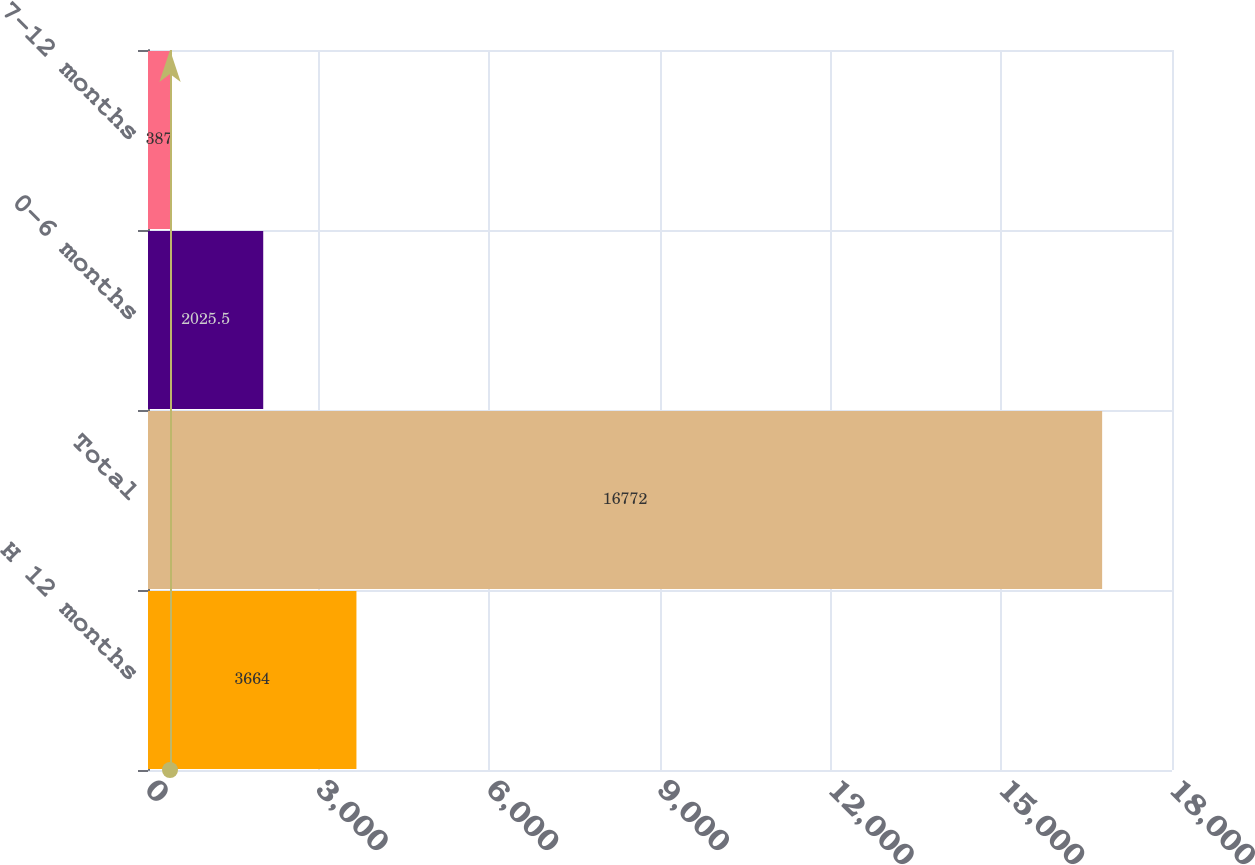Convert chart. <chart><loc_0><loc_0><loc_500><loc_500><bar_chart><fcel>H 12 months<fcel>Total<fcel>0-6 months<fcel>7-12 months<nl><fcel>3664<fcel>16772<fcel>2025.5<fcel>387<nl></chart> 